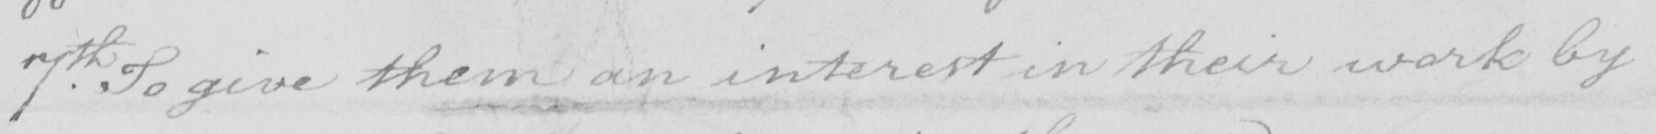Transcribe the text shown in this historical manuscript line. 7th . To give them an interest in their work by 